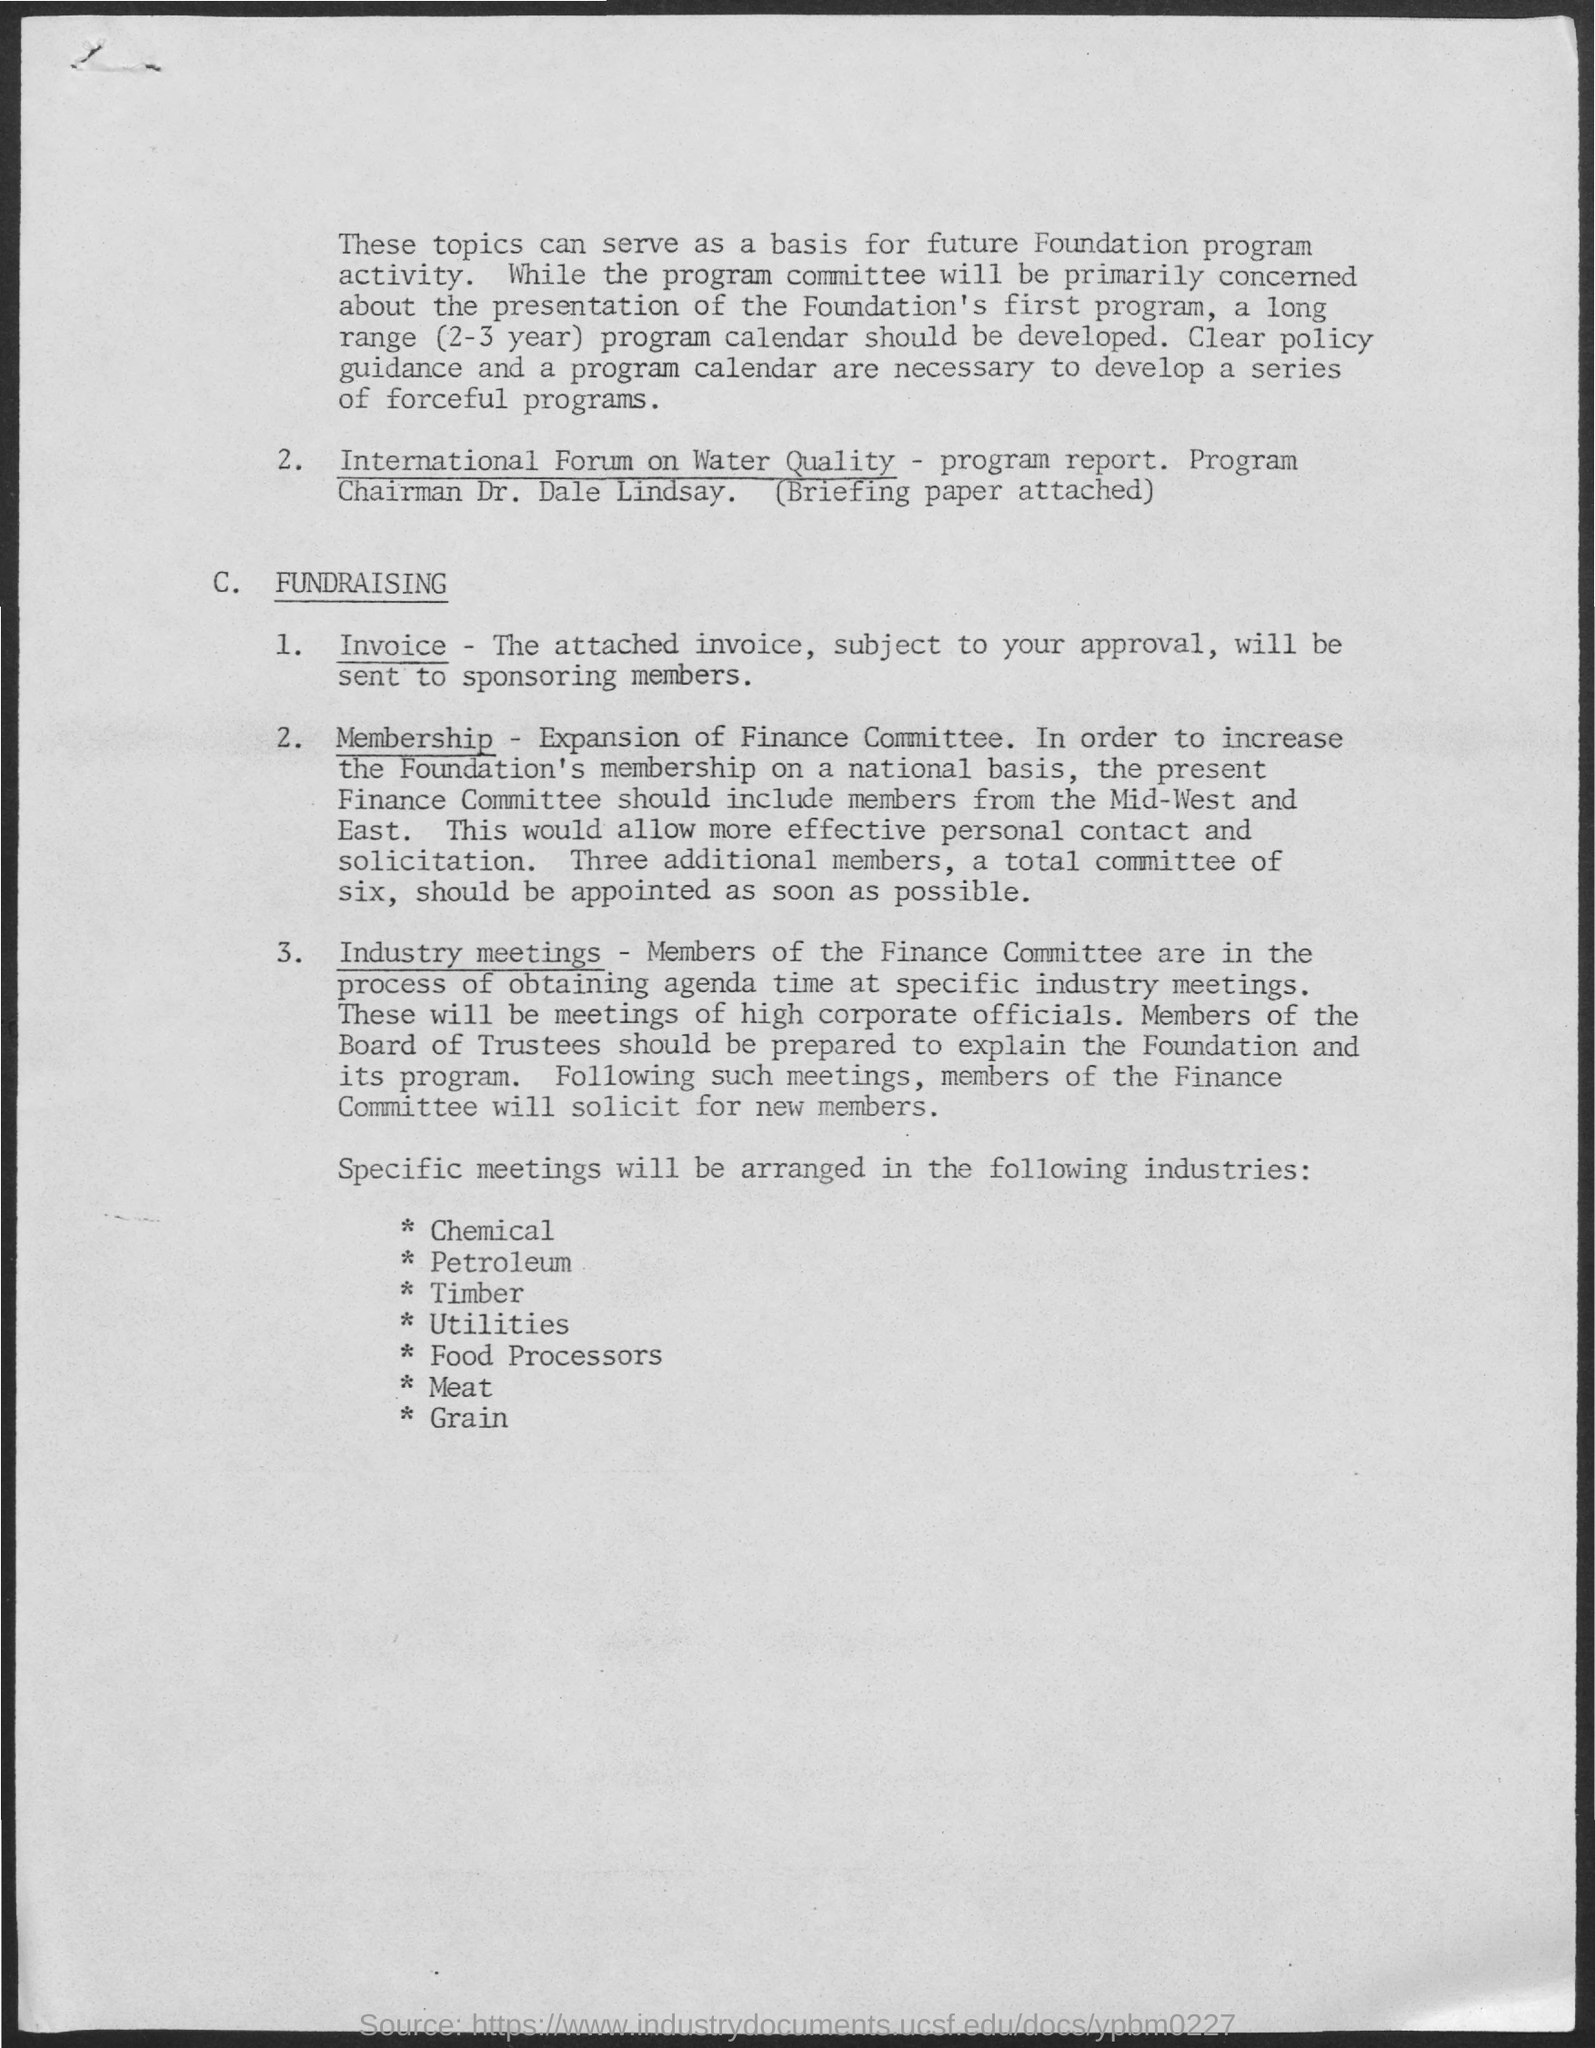Outline some significant characteristics in this image. The approved invoice has been sent to the sponsoring members. 